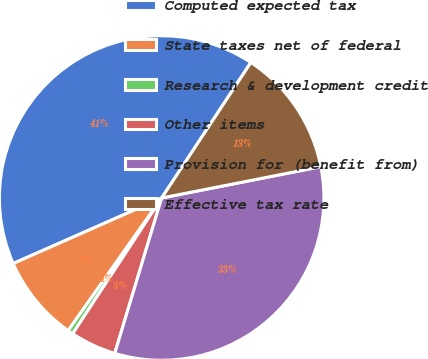Convert chart. <chart><loc_0><loc_0><loc_500><loc_500><pie_chart><fcel>Computed expected tax<fcel>State taxes net of federal<fcel>Research & development credit<fcel>Other items<fcel>Provision for (benefit from)<fcel>Effective tax rate<nl><fcel>40.89%<fcel>8.61%<fcel>0.54%<fcel>4.57%<fcel>32.76%<fcel>12.64%<nl></chart> 